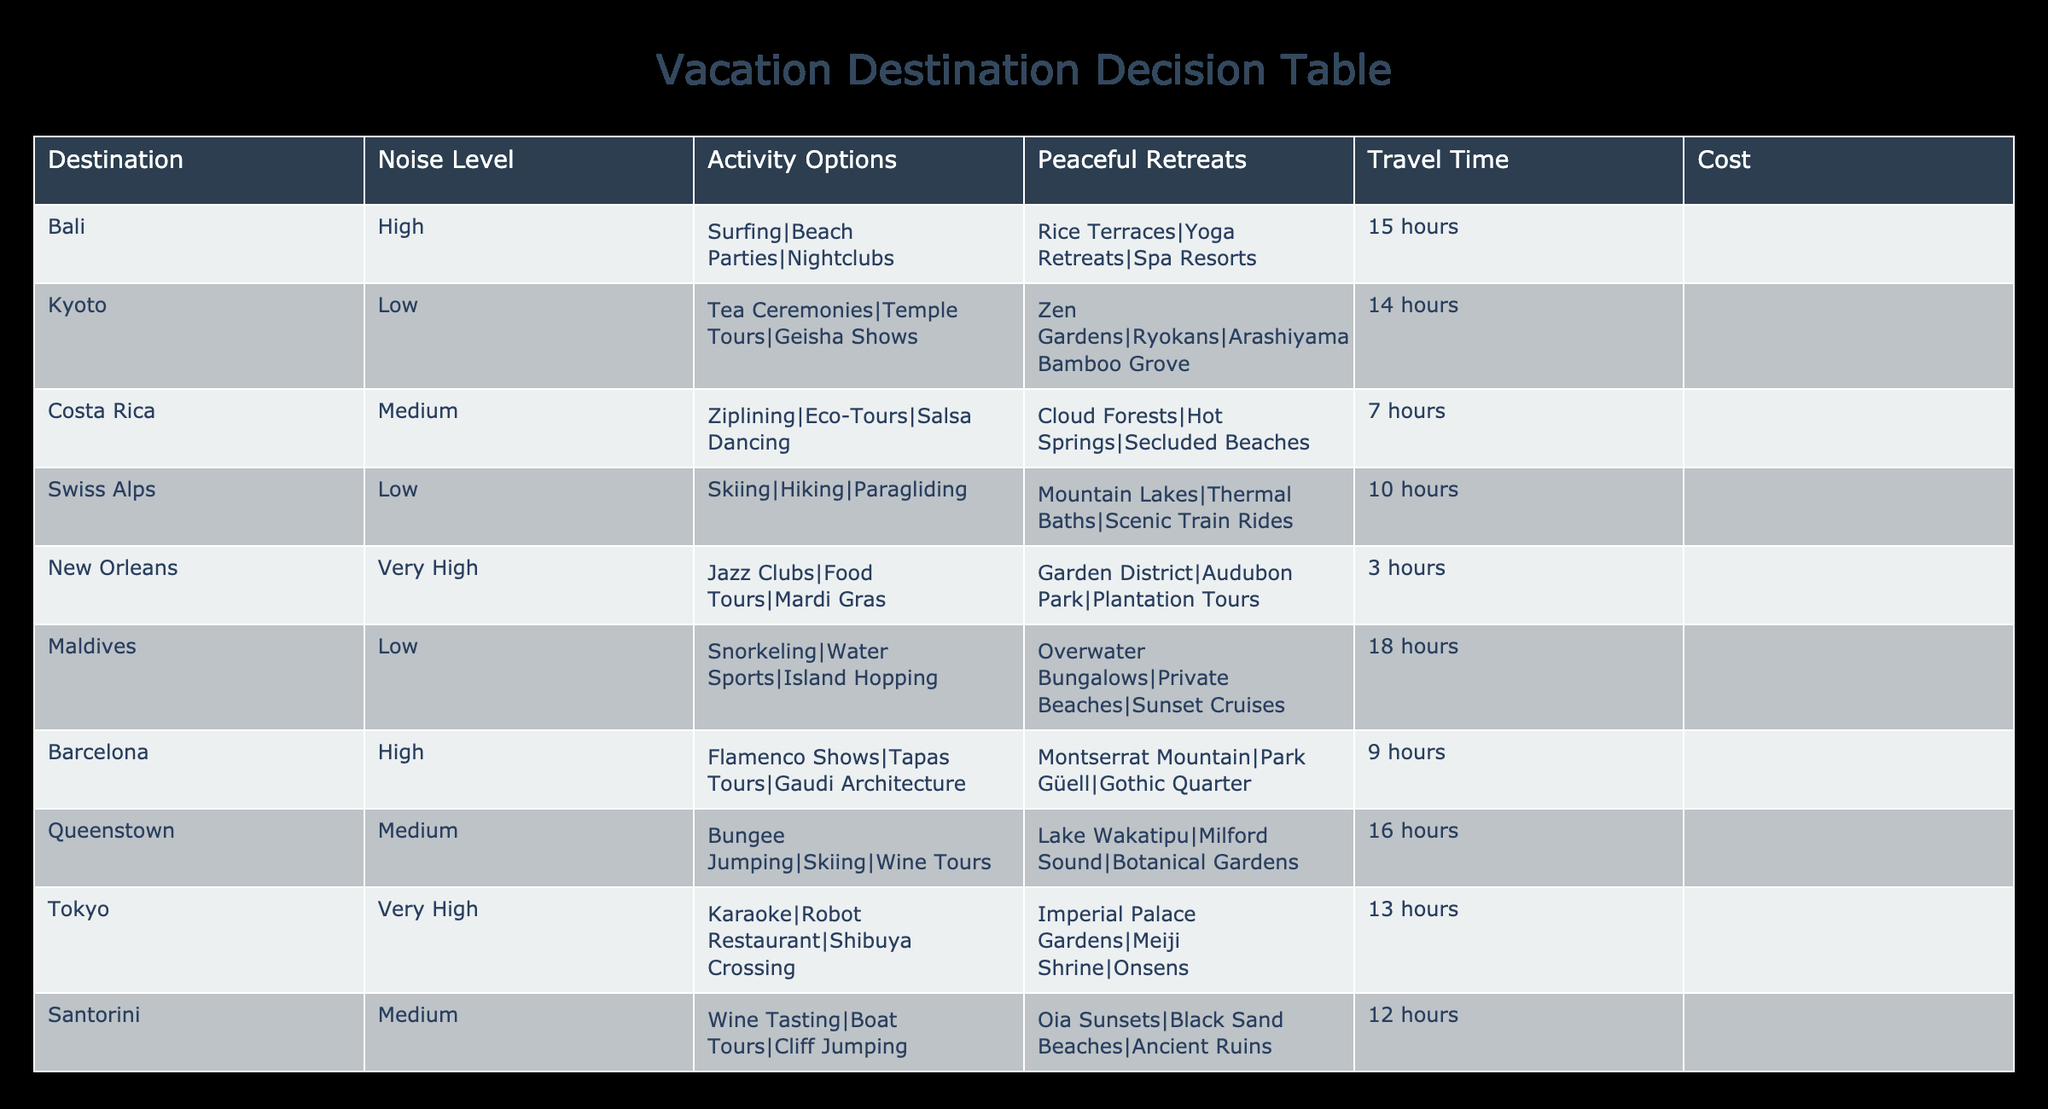What is the noise level of Bali? The table lists Bali's noise level under the "Noise Level" column, which is categorized as "High."
Answer: High Which destination has the lowest travel time? By examining the "Travel Time" column, we see that New Orleans has the shortest travel time of 3 hours.
Answer: 3 hours How many activity options does the Swiss Alps offer? The number of activity options can be found in the "Activity Options" column for Swiss Alps, which lists three options: Skiing, Hiking, and Paragliding.
Answer: 3 Is the Maldives a peaceful retreat destination? The table shows that the Maldives has peaceful retreats listed under "Peaceful Retreats," indicating that it indeed qualifies as a peaceful retreat destination.
Answer: Yes Which two destinations have a medium noise level? By checking the "Noise Level" column, we identify two destinations marked as "Medium," which are Costa Rica and Santorini.
Answer: Costa Rica, Santorini What is the average travel time of destinations with high noise levels? The high noise level destinations are Bali, Barcelona, and New Orleans. Their travel times are 15 hours, 9 hours, and 3 hours respectively. To find the average: (15 + 9 + 3) / 3 = 27 / 3 = 9 hours.
Answer: 9 hours Which destination has both lively activities and serene peaceful retreats? By analyzing the "Activity Options" and "Peaceful Retreats" columns, Costa Rica has lively activities like Ziplining and Eco-Tours, and peaceful retreats such as Cloud Forests and Secluded Beaches, showcasing a balance of both.
Answer: Costa Rica Is Tokyo more expensive than the Swiss Alps? Yes, Tokyo costs $$$$, while the Swiss Alps cost $$$, making Tokyo the more expensive option.
Answer: Yes How many destinations offer yoga retreats? Checking the "Peaceful Retreats" column, only Bali explicitly mentions yoga retreats among its options, which means there is one destination that offers this.
Answer: 1 